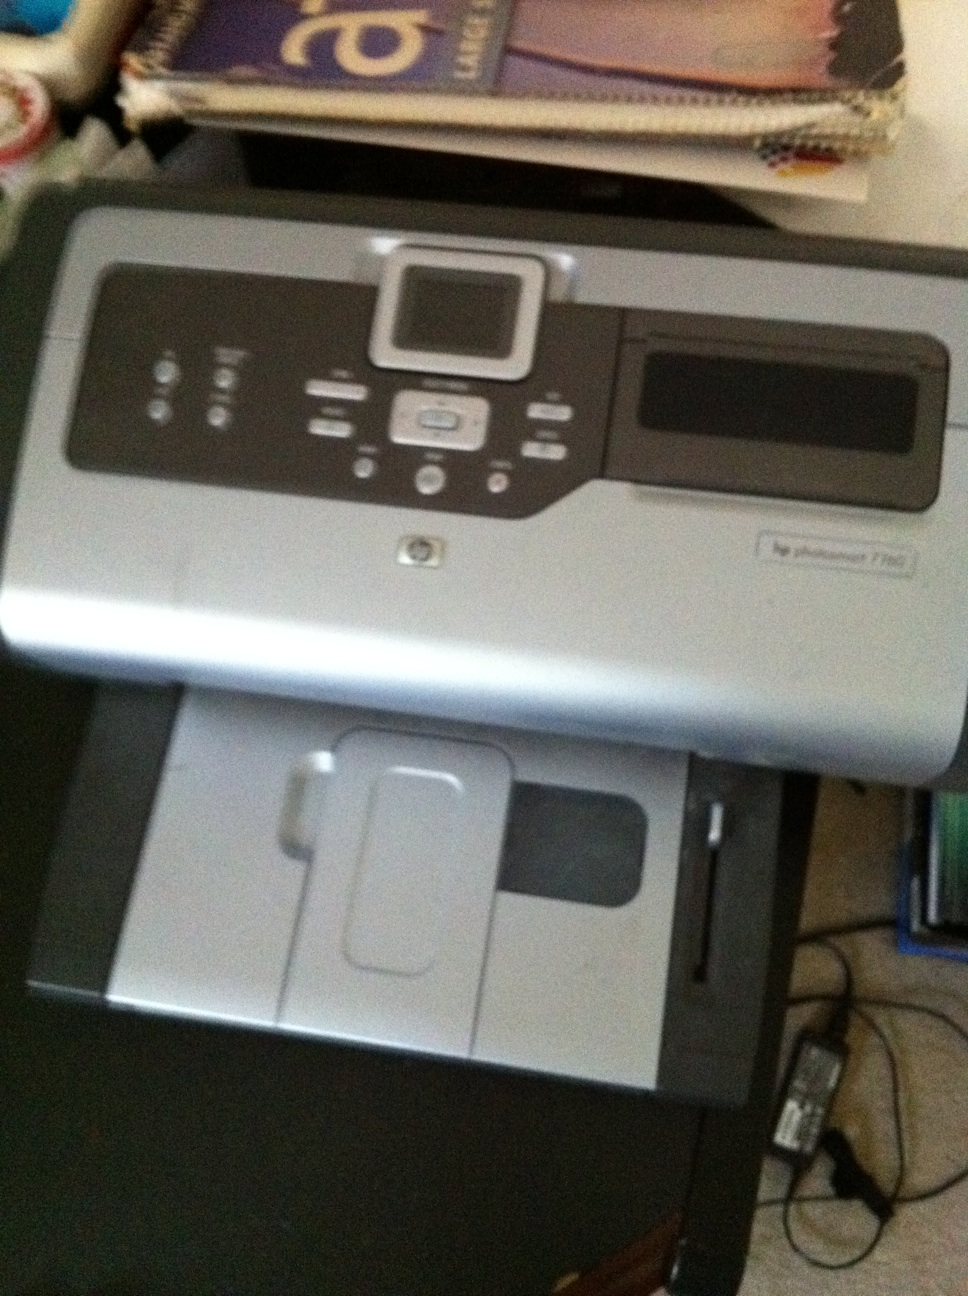What if the printer could talk? How would it help users? If the HP Photosmart 7280 printer could talk, it would remind users to regularly clean the printheads to ensure optimal performance and ink efficiency. It would provide real-time feedback on print jobs, alert users when paper or ink is running low, and suggest troubleshooting steps when issues arise. It could even offer tips on how to get the best print quality for different types of media and recommend maintenance routines to prolong the printer's lifespan. 